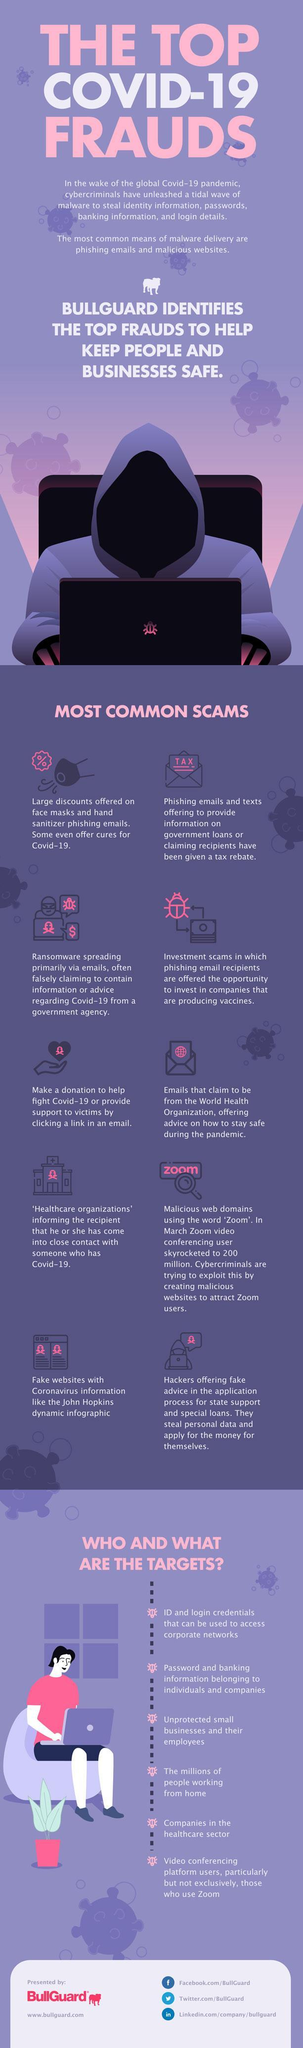How many scams mentioned in this infographic?
Answer the question with a short phrase. 10 